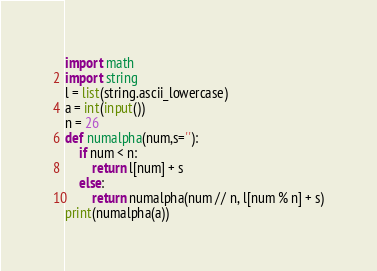<code> <loc_0><loc_0><loc_500><loc_500><_Python_>import math
import string
l = list(string.ascii_lowercase)
a = int(input())
n = 26
def numalpha(num,s=''):
    if num < n:
        return l[num] + s
    else:
        return numalpha(num // n, l[num % n] + s)
print(numalpha(a))</code> 